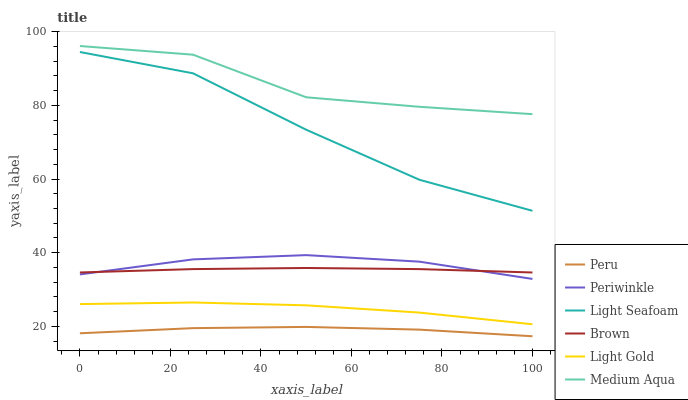Does Peru have the minimum area under the curve?
Answer yes or no. Yes. Does Medium Aqua have the maximum area under the curve?
Answer yes or no. Yes. Does Medium Aqua have the minimum area under the curve?
Answer yes or no. No. Does Peru have the maximum area under the curve?
Answer yes or no. No. Is Brown the smoothest?
Answer yes or no. Yes. Is Medium Aqua the roughest?
Answer yes or no. Yes. Is Peru the smoothest?
Answer yes or no. No. Is Peru the roughest?
Answer yes or no. No. Does Peru have the lowest value?
Answer yes or no. Yes. Does Medium Aqua have the lowest value?
Answer yes or no. No. Does Medium Aqua have the highest value?
Answer yes or no. Yes. Does Peru have the highest value?
Answer yes or no. No. Is Light Gold less than Light Seafoam?
Answer yes or no. Yes. Is Brown greater than Light Gold?
Answer yes or no. Yes. Does Periwinkle intersect Brown?
Answer yes or no. Yes. Is Periwinkle less than Brown?
Answer yes or no. No. Is Periwinkle greater than Brown?
Answer yes or no. No. Does Light Gold intersect Light Seafoam?
Answer yes or no. No. 